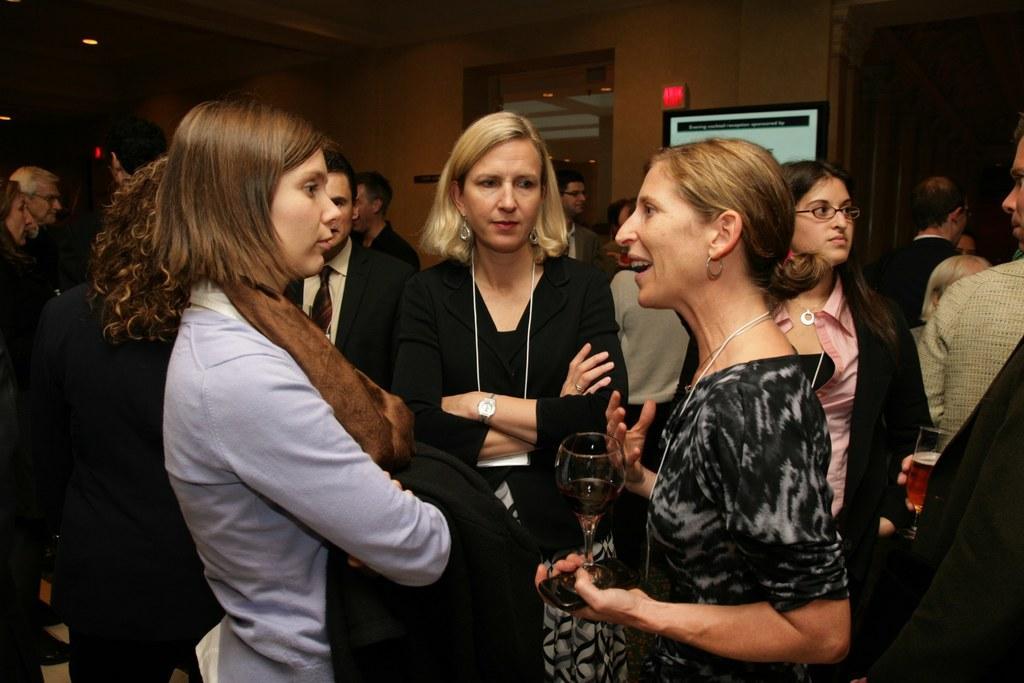Describe this image in one or two sentences. In this image there are group of persons standing and holding glass in their hands. In the background there is wall and on the wall there is an object which is red in colour and in front of the wall there is a monitor and on the top there are lights. 